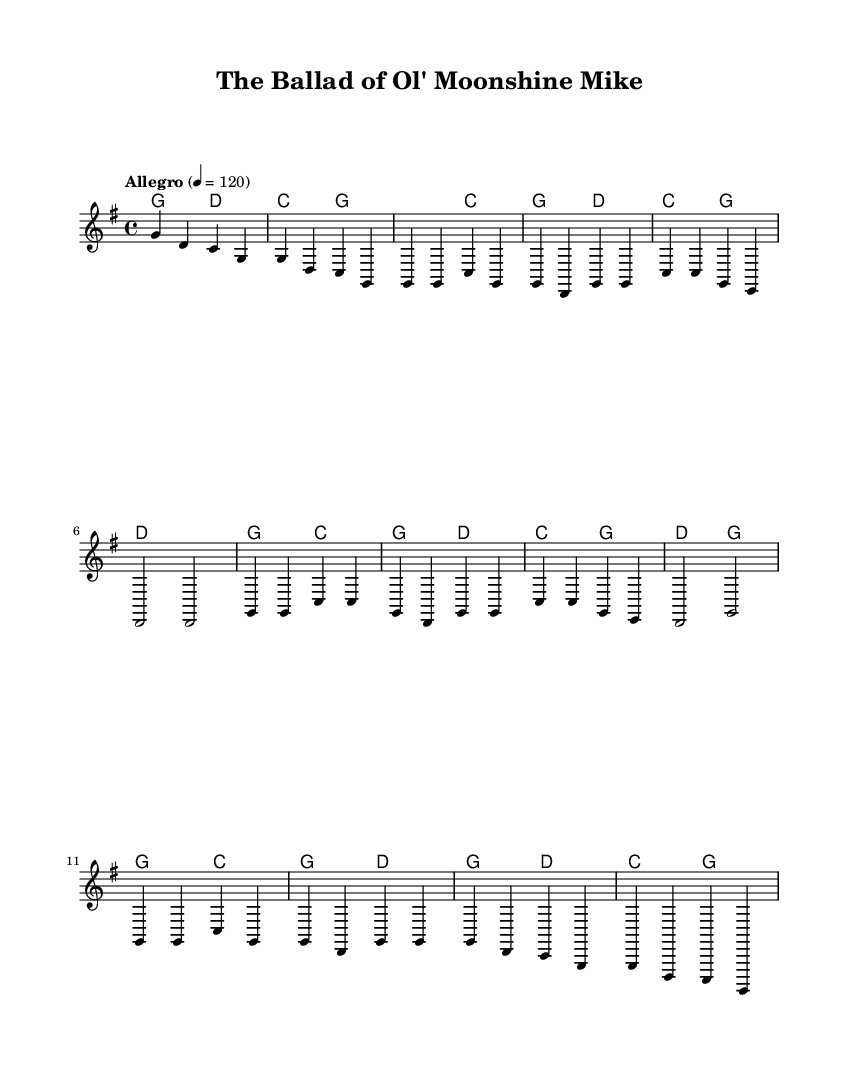What is the key signature of this music? The key signature is G major, which has one sharp (F#). This can be determined by looking at the key signature indication in the beginning of the sheet music.
Answer: G major What is the time signature for this composition? The time signature is 4/4, which signifies that there are four beats in each measure. This can be identified from the time signature notation at the beginning of the score.
Answer: 4/4 What is the tempo marking of this piece? The tempo marking is "Allegro," indicating that the piece should be played at a fast pace. This is visible in the tempo indication just below the global section.
Answer: Allegro How many measures are there in the first verse? There are four measures in the first verse as indicated by the notation and structure of the melody for that section. Each section (intro, verse 1, chorus, etc.) can be counted through the measure bars.
Answer: 4 What is the total number of verses in this piece? There are two verses in total as seen from the clear structure of the score, with Verse 1 specified followed by an abbreviated Verse 2 as noted.
Answer: 2 What chords are played during the chorus? The chords played during the chorus are G, C, and D. They can be found within the chord symbols indicated in the harmonies section during the chorus lines.
Answer: G, C, D What is the primary theme of the song based on the title? The primary theme is folklore, specifically celebrating a character named Moonshine Mike, as indicated by the title of the ballad. This suggests a narrative storytelling common in bluegrass music about local legends.
Answer: Folklore 